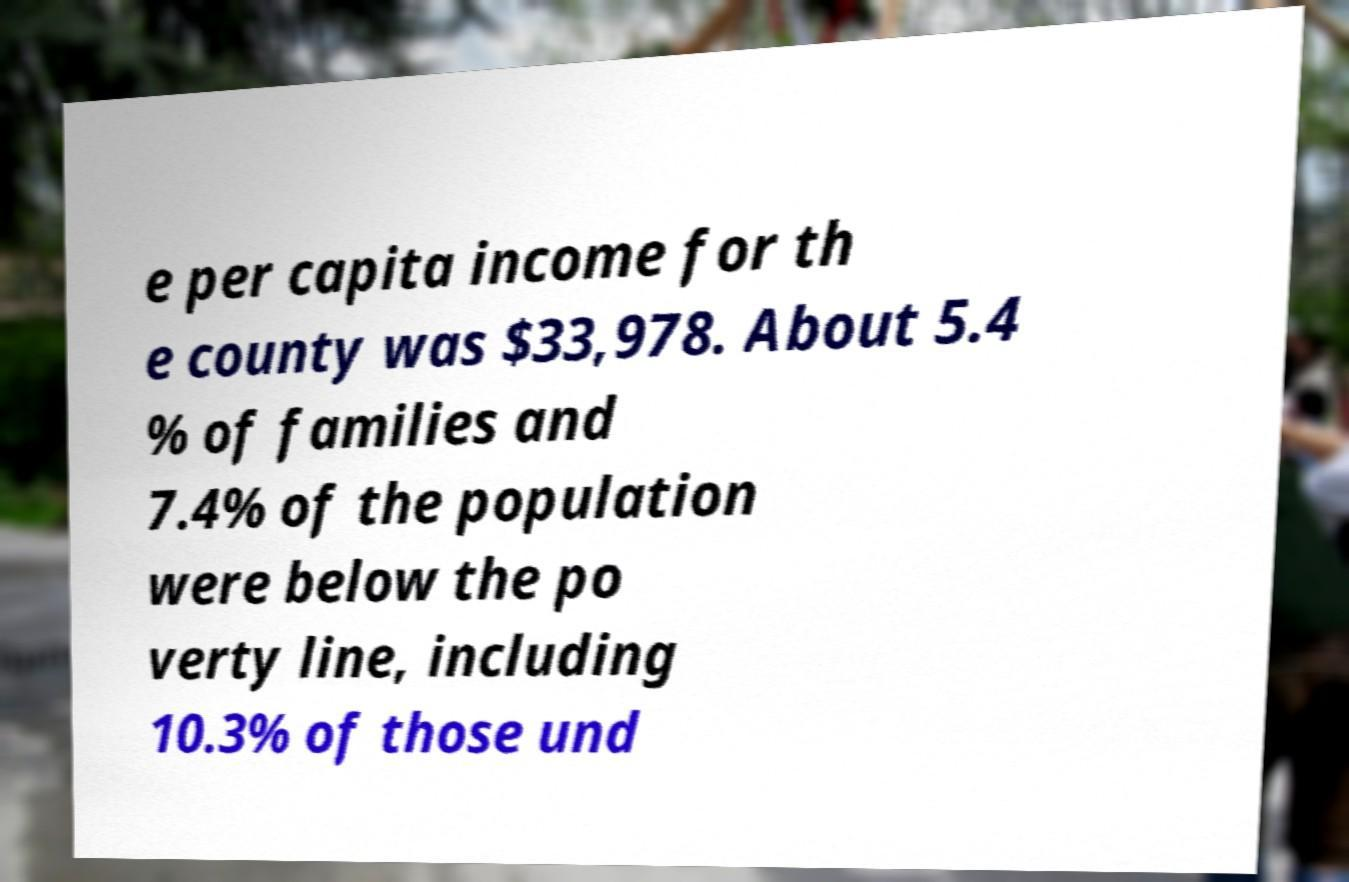Please identify and transcribe the text found in this image. e per capita income for th e county was $33,978. About 5.4 % of families and 7.4% of the population were below the po verty line, including 10.3% of those und 